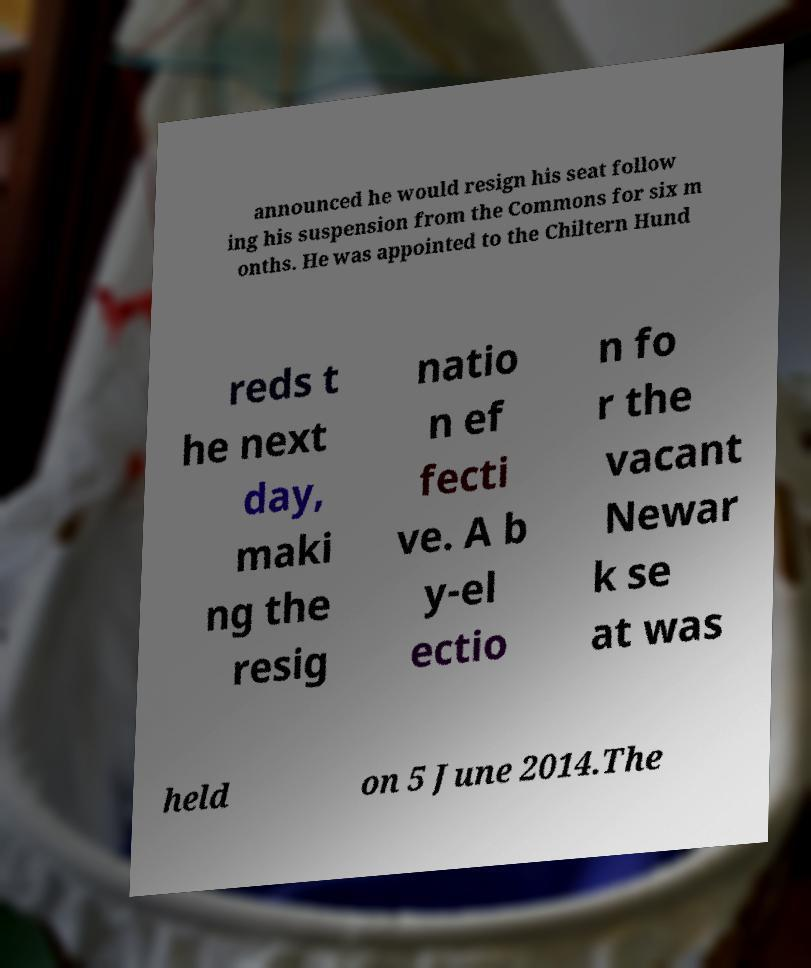I need the written content from this picture converted into text. Can you do that? announced he would resign his seat follow ing his suspension from the Commons for six m onths. He was appointed to the Chiltern Hund reds t he next day, maki ng the resig natio n ef fecti ve. A b y-el ectio n fo r the vacant Newar k se at was held on 5 June 2014.The 